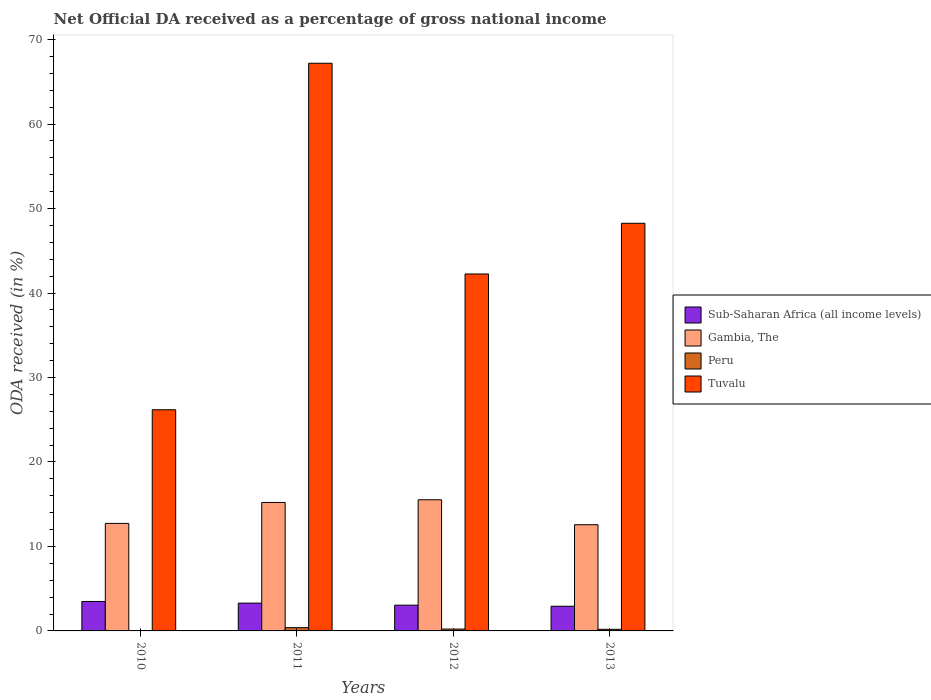How many different coloured bars are there?
Provide a short and direct response. 4. Are the number of bars per tick equal to the number of legend labels?
Keep it short and to the point. No. Are the number of bars on each tick of the X-axis equal?
Ensure brevity in your answer.  No. How many bars are there on the 3rd tick from the left?
Your response must be concise. 4. In how many cases, is the number of bars for a given year not equal to the number of legend labels?
Keep it short and to the point. 1. What is the net official DA received in Gambia, The in 2012?
Provide a succinct answer. 15.53. Across all years, what is the maximum net official DA received in Sub-Saharan Africa (all income levels)?
Provide a succinct answer. 3.48. In which year was the net official DA received in Peru maximum?
Offer a very short reply. 2011. What is the total net official DA received in Gambia, The in the graph?
Offer a terse response. 56.03. What is the difference between the net official DA received in Gambia, The in 2010 and that in 2013?
Offer a very short reply. 0.16. What is the difference between the net official DA received in Tuvalu in 2011 and the net official DA received in Gambia, The in 2010?
Your answer should be compact. 54.47. What is the average net official DA received in Gambia, The per year?
Ensure brevity in your answer.  14.01. In the year 2013, what is the difference between the net official DA received in Sub-Saharan Africa (all income levels) and net official DA received in Peru?
Provide a succinct answer. 2.73. In how many years, is the net official DA received in Peru greater than 52 %?
Give a very brief answer. 0. What is the ratio of the net official DA received in Gambia, The in 2011 to that in 2013?
Keep it short and to the point. 1.21. Is the net official DA received in Peru in 2011 less than that in 2012?
Keep it short and to the point. No. What is the difference between the highest and the second highest net official DA received in Gambia, The?
Make the answer very short. 0.32. What is the difference between the highest and the lowest net official DA received in Sub-Saharan Africa (all income levels)?
Make the answer very short. 0.56. Is it the case that in every year, the sum of the net official DA received in Tuvalu and net official DA received in Sub-Saharan Africa (all income levels) is greater than the sum of net official DA received in Peru and net official DA received in Gambia, The?
Make the answer very short. Yes. Is it the case that in every year, the sum of the net official DA received in Sub-Saharan Africa (all income levels) and net official DA received in Gambia, The is greater than the net official DA received in Tuvalu?
Ensure brevity in your answer.  No. How many bars are there?
Provide a succinct answer. 15. How many years are there in the graph?
Offer a very short reply. 4. Does the graph contain any zero values?
Keep it short and to the point. Yes. Where does the legend appear in the graph?
Your answer should be compact. Center right. How are the legend labels stacked?
Make the answer very short. Vertical. What is the title of the graph?
Make the answer very short. Net Official DA received as a percentage of gross national income. What is the label or title of the Y-axis?
Offer a terse response. ODA received (in %). What is the ODA received (in %) of Sub-Saharan Africa (all income levels) in 2010?
Keep it short and to the point. 3.48. What is the ODA received (in %) of Gambia, The in 2010?
Make the answer very short. 12.73. What is the ODA received (in %) in Tuvalu in 2010?
Keep it short and to the point. 26.18. What is the ODA received (in %) in Sub-Saharan Africa (all income levels) in 2011?
Provide a short and direct response. 3.29. What is the ODA received (in %) of Gambia, The in 2011?
Ensure brevity in your answer.  15.21. What is the ODA received (in %) in Peru in 2011?
Give a very brief answer. 0.38. What is the ODA received (in %) in Tuvalu in 2011?
Keep it short and to the point. 67.2. What is the ODA received (in %) in Sub-Saharan Africa (all income levels) in 2012?
Your answer should be very brief. 3.05. What is the ODA received (in %) of Gambia, The in 2012?
Your response must be concise. 15.53. What is the ODA received (in %) in Peru in 2012?
Offer a terse response. 0.22. What is the ODA received (in %) of Tuvalu in 2012?
Provide a succinct answer. 42.25. What is the ODA received (in %) of Sub-Saharan Africa (all income levels) in 2013?
Offer a terse response. 2.92. What is the ODA received (in %) of Gambia, The in 2013?
Your answer should be very brief. 12.57. What is the ODA received (in %) in Peru in 2013?
Your response must be concise. 0.19. What is the ODA received (in %) in Tuvalu in 2013?
Offer a very short reply. 48.25. Across all years, what is the maximum ODA received (in %) of Sub-Saharan Africa (all income levels)?
Keep it short and to the point. 3.48. Across all years, what is the maximum ODA received (in %) in Gambia, The?
Provide a short and direct response. 15.53. Across all years, what is the maximum ODA received (in %) in Peru?
Keep it short and to the point. 0.38. Across all years, what is the maximum ODA received (in %) of Tuvalu?
Make the answer very short. 67.2. Across all years, what is the minimum ODA received (in %) of Sub-Saharan Africa (all income levels)?
Offer a terse response. 2.92. Across all years, what is the minimum ODA received (in %) in Gambia, The?
Provide a short and direct response. 12.57. Across all years, what is the minimum ODA received (in %) in Peru?
Your response must be concise. 0. Across all years, what is the minimum ODA received (in %) in Tuvalu?
Give a very brief answer. 26.18. What is the total ODA received (in %) of Sub-Saharan Africa (all income levels) in the graph?
Provide a short and direct response. 12.75. What is the total ODA received (in %) of Gambia, The in the graph?
Provide a succinct answer. 56.03. What is the total ODA received (in %) in Peru in the graph?
Provide a short and direct response. 0.8. What is the total ODA received (in %) in Tuvalu in the graph?
Provide a succinct answer. 183.88. What is the difference between the ODA received (in %) of Sub-Saharan Africa (all income levels) in 2010 and that in 2011?
Provide a succinct answer. 0.19. What is the difference between the ODA received (in %) of Gambia, The in 2010 and that in 2011?
Make the answer very short. -2.48. What is the difference between the ODA received (in %) of Tuvalu in 2010 and that in 2011?
Your answer should be compact. -41.02. What is the difference between the ODA received (in %) of Sub-Saharan Africa (all income levels) in 2010 and that in 2012?
Provide a succinct answer. 0.44. What is the difference between the ODA received (in %) of Gambia, The in 2010 and that in 2012?
Ensure brevity in your answer.  -2.8. What is the difference between the ODA received (in %) of Tuvalu in 2010 and that in 2012?
Provide a succinct answer. -16.07. What is the difference between the ODA received (in %) in Sub-Saharan Africa (all income levels) in 2010 and that in 2013?
Provide a succinct answer. 0.56. What is the difference between the ODA received (in %) in Gambia, The in 2010 and that in 2013?
Ensure brevity in your answer.  0.16. What is the difference between the ODA received (in %) of Tuvalu in 2010 and that in 2013?
Offer a terse response. -22.07. What is the difference between the ODA received (in %) of Sub-Saharan Africa (all income levels) in 2011 and that in 2012?
Offer a terse response. 0.24. What is the difference between the ODA received (in %) in Gambia, The in 2011 and that in 2012?
Give a very brief answer. -0.32. What is the difference between the ODA received (in %) of Peru in 2011 and that in 2012?
Your answer should be compact. 0.17. What is the difference between the ODA received (in %) of Tuvalu in 2011 and that in 2012?
Keep it short and to the point. 24.94. What is the difference between the ODA received (in %) in Sub-Saharan Africa (all income levels) in 2011 and that in 2013?
Provide a succinct answer. 0.37. What is the difference between the ODA received (in %) in Gambia, The in 2011 and that in 2013?
Your answer should be compact. 2.63. What is the difference between the ODA received (in %) of Peru in 2011 and that in 2013?
Provide a short and direct response. 0.19. What is the difference between the ODA received (in %) of Tuvalu in 2011 and that in 2013?
Offer a very short reply. 18.94. What is the difference between the ODA received (in %) of Sub-Saharan Africa (all income levels) in 2012 and that in 2013?
Your response must be concise. 0.13. What is the difference between the ODA received (in %) in Gambia, The in 2012 and that in 2013?
Give a very brief answer. 2.96. What is the difference between the ODA received (in %) of Peru in 2012 and that in 2013?
Keep it short and to the point. 0.03. What is the difference between the ODA received (in %) in Tuvalu in 2012 and that in 2013?
Keep it short and to the point. -6. What is the difference between the ODA received (in %) of Sub-Saharan Africa (all income levels) in 2010 and the ODA received (in %) of Gambia, The in 2011?
Offer a terse response. -11.72. What is the difference between the ODA received (in %) in Sub-Saharan Africa (all income levels) in 2010 and the ODA received (in %) in Peru in 2011?
Make the answer very short. 3.1. What is the difference between the ODA received (in %) in Sub-Saharan Africa (all income levels) in 2010 and the ODA received (in %) in Tuvalu in 2011?
Ensure brevity in your answer.  -63.71. What is the difference between the ODA received (in %) of Gambia, The in 2010 and the ODA received (in %) of Peru in 2011?
Keep it short and to the point. 12.34. What is the difference between the ODA received (in %) in Gambia, The in 2010 and the ODA received (in %) in Tuvalu in 2011?
Make the answer very short. -54.47. What is the difference between the ODA received (in %) of Sub-Saharan Africa (all income levels) in 2010 and the ODA received (in %) of Gambia, The in 2012?
Offer a very short reply. -12.04. What is the difference between the ODA received (in %) in Sub-Saharan Africa (all income levels) in 2010 and the ODA received (in %) in Peru in 2012?
Offer a terse response. 3.27. What is the difference between the ODA received (in %) of Sub-Saharan Africa (all income levels) in 2010 and the ODA received (in %) of Tuvalu in 2012?
Your response must be concise. -38.77. What is the difference between the ODA received (in %) in Gambia, The in 2010 and the ODA received (in %) in Peru in 2012?
Provide a succinct answer. 12.51. What is the difference between the ODA received (in %) in Gambia, The in 2010 and the ODA received (in %) in Tuvalu in 2012?
Your answer should be compact. -29.52. What is the difference between the ODA received (in %) of Sub-Saharan Africa (all income levels) in 2010 and the ODA received (in %) of Gambia, The in 2013?
Your answer should be very brief. -9.09. What is the difference between the ODA received (in %) in Sub-Saharan Africa (all income levels) in 2010 and the ODA received (in %) in Peru in 2013?
Provide a short and direct response. 3.29. What is the difference between the ODA received (in %) of Sub-Saharan Africa (all income levels) in 2010 and the ODA received (in %) of Tuvalu in 2013?
Provide a succinct answer. -44.77. What is the difference between the ODA received (in %) in Gambia, The in 2010 and the ODA received (in %) in Peru in 2013?
Offer a terse response. 12.54. What is the difference between the ODA received (in %) of Gambia, The in 2010 and the ODA received (in %) of Tuvalu in 2013?
Offer a terse response. -35.52. What is the difference between the ODA received (in %) of Sub-Saharan Africa (all income levels) in 2011 and the ODA received (in %) of Gambia, The in 2012?
Offer a very short reply. -12.24. What is the difference between the ODA received (in %) of Sub-Saharan Africa (all income levels) in 2011 and the ODA received (in %) of Peru in 2012?
Keep it short and to the point. 3.07. What is the difference between the ODA received (in %) of Sub-Saharan Africa (all income levels) in 2011 and the ODA received (in %) of Tuvalu in 2012?
Offer a terse response. -38.96. What is the difference between the ODA received (in %) of Gambia, The in 2011 and the ODA received (in %) of Peru in 2012?
Provide a short and direct response. 14.99. What is the difference between the ODA received (in %) in Gambia, The in 2011 and the ODA received (in %) in Tuvalu in 2012?
Offer a terse response. -27.05. What is the difference between the ODA received (in %) in Peru in 2011 and the ODA received (in %) in Tuvalu in 2012?
Offer a terse response. -41.87. What is the difference between the ODA received (in %) of Sub-Saharan Africa (all income levels) in 2011 and the ODA received (in %) of Gambia, The in 2013?
Provide a succinct answer. -9.28. What is the difference between the ODA received (in %) of Sub-Saharan Africa (all income levels) in 2011 and the ODA received (in %) of Peru in 2013?
Give a very brief answer. 3.1. What is the difference between the ODA received (in %) in Sub-Saharan Africa (all income levels) in 2011 and the ODA received (in %) in Tuvalu in 2013?
Ensure brevity in your answer.  -44.96. What is the difference between the ODA received (in %) in Gambia, The in 2011 and the ODA received (in %) in Peru in 2013?
Your response must be concise. 15.01. What is the difference between the ODA received (in %) in Gambia, The in 2011 and the ODA received (in %) in Tuvalu in 2013?
Make the answer very short. -33.05. What is the difference between the ODA received (in %) in Peru in 2011 and the ODA received (in %) in Tuvalu in 2013?
Your answer should be very brief. -47.87. What is the difference between the ODA received (in %) of Sub-Saharan Africa (all income levels) in 2012 and the ODA received (in %) of Gambia, The in 2013?
Provide a short and direct response. -9.52. What is the difference between the ODA received (in %) in Sub-Saharan Africa (all income levels) in 2012 and the ODA received (in %) in Peru in 2013?
Offer a terse response. 2.86. What is the difference between the ODA received (in %) of Sub-Saharan Africa (all income levels) in 2012 and the ODA received (in %) of Tuvalu in 2013?
Offer a very short reply. -45.2. What is the difference between the ODA received (in %) in Gambia, The in 2012 and the ODA received (in %) in Peru in 2013?
Your answer should be compact. 15.33. What is the difference between the ODA received (in %) in Gambia, The in 2012 and the ODA received (in %) in Tuvalu in 2013?
Offer a terse response. -32.72. What is the difference between the ODA received (in %) in Peru in 2012 and the ODA received (in %) in Tuvalu in 2013?
Your answer should be compact. -48.03. What is the average ODA received (in %) in Sub-Saharan Africa (all income levels) per year?
Offer a very short reply. 3.19. What is the average ODA received (in %) of Gambia, The per year?
Your answer should be very brief. 14.01. What is the average ODA received (in %) of Peru per year?
Offer a terse response. 0.2. What is the average ODA received (in %) in Tuvalu per year?
Your answer should be compact. 45.97. In the year 2010, what is the difference between the ODA received (in %) of Sub-Saharan Africa (all income levels) and ODA received (in %) of Gambia, The?
Offer a terse response. -9.24. In the year 2010, what is the difference between the ODA received (in %) in Sub-Saharan Africa (all income levels) and ODA received (in %) in Tuvalu?
Provide a succinct answer. -22.69. In the year 2010, what is the difference between the ODA received (in %) in Gambia, The and ODA received (in %) in Tuvalu?
Your answer should be very brief. -13.45. In the year 2011, what is the difference between the ODA received (in %) in Sub-Saharan Africa (all income levels) and ODA received (in %) in Gambia, The?
Give a very brief answer. -11.91. In the year 2011, what is the difference between the ODA received (in %) in Sub-Saharan Africa (all income levels) and ODA received (in %) in Peru?
Offer a very short reply. 2.91. In the year 2011, what is the difference between the ODA received (in %) of Sub-Saharan Africa (all income levels) and ODA received (in %) of Tuvalu?
Make the answer very short. -63.9. In the year 2011, what is the difference between the ODA received (in %) in Gambia, The and ODA received (in %) in Peru?
Keep it short and to the point. 14.82. In the year 2011, what is the difference between the ODA received (in %) of Gambia, The and ODA received (in %) of Tuvalu?
Your answer should be very brief. -51.99. In the year 2011, what is the difference between the ODA received (in %) in Peru and ODA received (in %) in Tuvalu?
Ensure brevity in your answer.  -66.81. In the year 2012, what is the difference between the ODA received (in %) of Sub-Saharan Africa (all income levels) and ODA received (in %) of Gambia, The?
Provide a short and direct response. -12.48. In the year 2012, what is the difference between the ODA received (in %) in Sub-Saharan Africa (all income levels) and ODA received (in %) in Peru?
Your answer should be very brief. 2.83. In the year 2012, what is the difference between the ODA received (in %) of Sub-Saharan Africa (all income levels) and ODA received (in %) of Tuvalu?
Provide a short and direct response. -39.2. In the year 2012, what is the difference between the ODA received (in %) of Gambia, The and ODA received (in %) of Peru?
Offer a very short reply. 15.31. In the year 2012, what is the difference between the ODA received (in %) in Gambia, The and ODA received (in %) in Tuvalu?
Provide a succinct answer. -26.72. In the year 2012, what is the difference between the ODA received (in %) of Peru and ODA received (in %) of Tuvalu?
Make the answer very short. -42.03. In the year 2013, what is the difference between the ODA received (in %) in Sub-Saharan Africa (all income levels) and ODA received (in %) in Gambia, The?
Your answer should be compact. -9.65. In the year 2013, what is the difference between the ODA received (in %) in Sub-Saharan Africa (all income levels) and ODA received (in %) in Peru?
Ensure brevity in your answer.  2.73. In the year 2013, what is the difference between the ODA received (in %) of Sub-Saharan Africa (all income levels) and ODA received (in %) of Tuvalu?
Your response must be concise. -45.33. In the year 2013, what is the difference between the ODA received (in %) of Gambia, The and ODA received (in %) of Peru?
Offer a very short reply. 12.38. In the year 2013, what is the difference between the ODA received (in %) in Gambia, The and ODA received (in %) in Tuvalu?
Provide a short and direct response. -35.68. In the year 2013, what is the difference between the ODA received (in %) of Peru and ODA received (in %) of Tuvalu?
Your answer should be very brief. -48.06. What is the ratio of the ODA received (in %) in Sub-Saharan Africa (all income levels) in 2010 to that in 2011?
Give a very brief answer. 1.06. What is the ratio of the ODA received (in %) in Gambia, The in 2010 to that in 2011?
Your answer should be compact. 0.84. What is the ratio of the ODA received (in %) in Tuvalu in 2010 to that in 2011?
Give a very brief answer. 0.39. What is the ratio of the ODA received (in %) of Gambia, The in 2010 to that in 2012?
Offer a very short reply. 0.82. What is the ratio of the ODA received (in %) of Tuvalu in 2010 to that in 2012?
Make the answer very short. 0.62. What is the ratio of the ODA received (in %) in Sub-Saharan Africa (all income levels) in 2010 to that in 2013?
Offer a very short reply. 1.19. What is the ratio of the ODA received (in %) in Gambia, The in 2010 to that in 2013?
Offer a terse response. 1.01. What is the ratio of the ODA received (in %) of Tuvalu in 2010 to that in 2013?
Keep it short and to the point. 0.54. What is the ratio of the ODA received (in %) of Sub-Saharan Africa (all income levels) in 2011 to that in 2012?
Give a very brief answer. 1.08. What is the ratio of the ODA received (in %) in Gambia, The in 2011 to that in 2012?
Your answer should be very brief. 0.98. What is the ratio of the ODA received (in %) in Peru in 2011 to that in 2012?
Offer a very short reply. 1.76. What is the ratio of the ODA received (in %) in Tuvalu in 2011 to that in 2012?
Your answer should be compact. 1.59. What is the ratio of the ODA received (in %) in Sub-Saharan Africa (all income levels) in 2011 to that in 2013?
Ensure brevity in your answer.  1.13. What is the ratio of the ODA received (in %) of Gambia, The in 2011 to that in 2013?
Your answer should be very brief. 1.21. What is the ratio of the ODA received (in %) in Peru in 2011 to that in 2013?
Keep it short and to the point. 2. What is the ratio of the ODA received (in %) in Tuvalu in 2011 to that in 2013?
Keep it short and to the point. 1.39. What is the ratio of the ODA received (in %) in Sub-Saharan Africa (all income levels) in 2012 to that in 2013?
Your answer should be very brief. 1.04. What is the ratio of the ODA received (in %) of Gambia, The in 2012 to that in 2013?
Your answer should be very brief. 1.24. What is the ratio of the ODA received (in %) of Peru in 2012 to that in 2013?
Make the answer very short. 1.14. What is the ratio of the ODA received (in %) of Tuvalu in 2012 to that in 2013?
Keep it short and to the point. 0.88. What is the difference between the highest and the second highest ODA received (in %) in Sub-Saharan Africa (all income levels)?
Ensure brevity in your answer.  0.19. What is the difference between the highest and the second highest ODA received (in %) in Gambia, The?
Keep it short and to the point. 0.32. What is the difference between the highest and the second highest ODA received (in %) in Peru?
Provide a short and direct response. 0.17. What is the difference between the highest and the second highest ODA received (in %) of Tuvalu?
Your response must be concise. 18.94. What is the difference between the highest and the lowest ODA received (in %) in Sub-Saharan Africa (all income levels)?
Offer a very short reply. 0.56. What is the difference between the highest and the lowest ODA received (in %) in Gambia, The?
Offer a terse response. 2.96. What is the difference between the highest and the lowest ODA received (in %) of Peru?
Offer a very short reply. 0.38. What is the difference between the highest and the lowest ODA received (in %) of Tuvalu?
Ensure brevity in your answer.  41.02. 